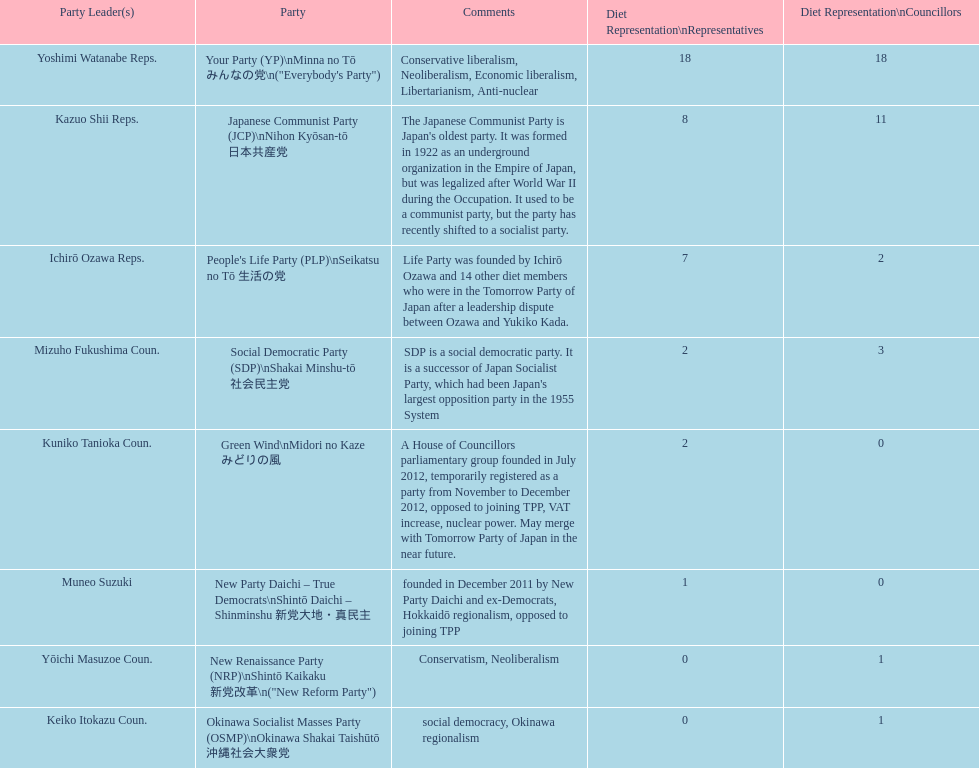What party has the most representatives in the diet representation? Your Party. 